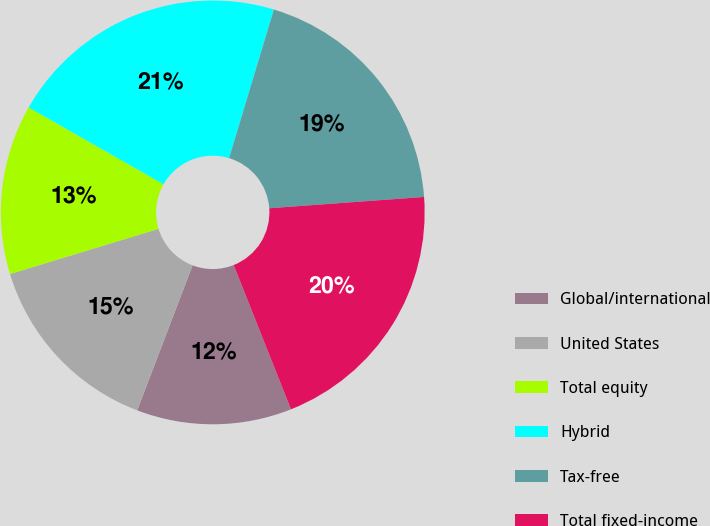Convert chart to OTSL. <chart><loc_0><loc_0><loc_500><loc_500><pie_chart><fcel>Global/international<fcel>United States<fcel>Total equity<fcel>Hybrid<fcel>Tax-free<fcel>Total fixed-income<nl><fcel>11.82%<fcel>14.5%<fcel>12.94%<fcel>21.41%<fcel>19.18%<fcel>20.14%<nl></chart> 